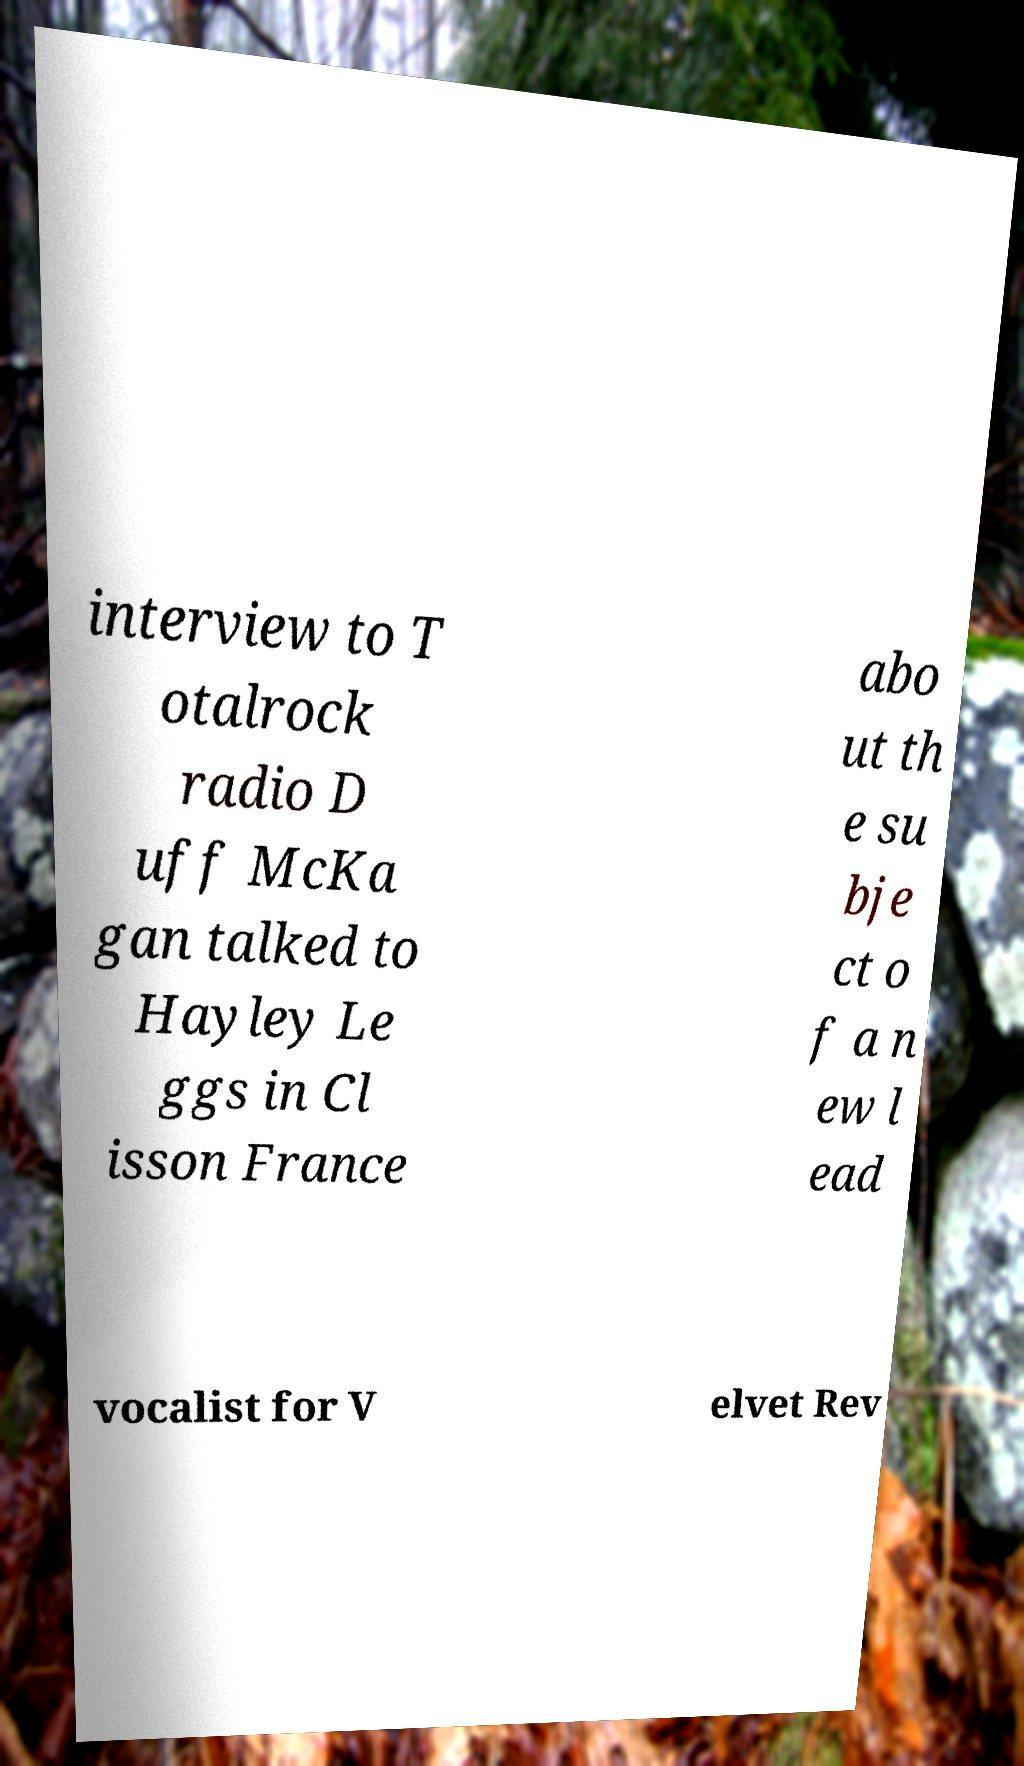Could you extract and type out the text from this image? interview to T otalrock radio D uff McKa gan talked to Hayley Le ggs in Cl isson France abo ut th e su bje ct o f a n ew l ead vocalist for V elvet Rev 